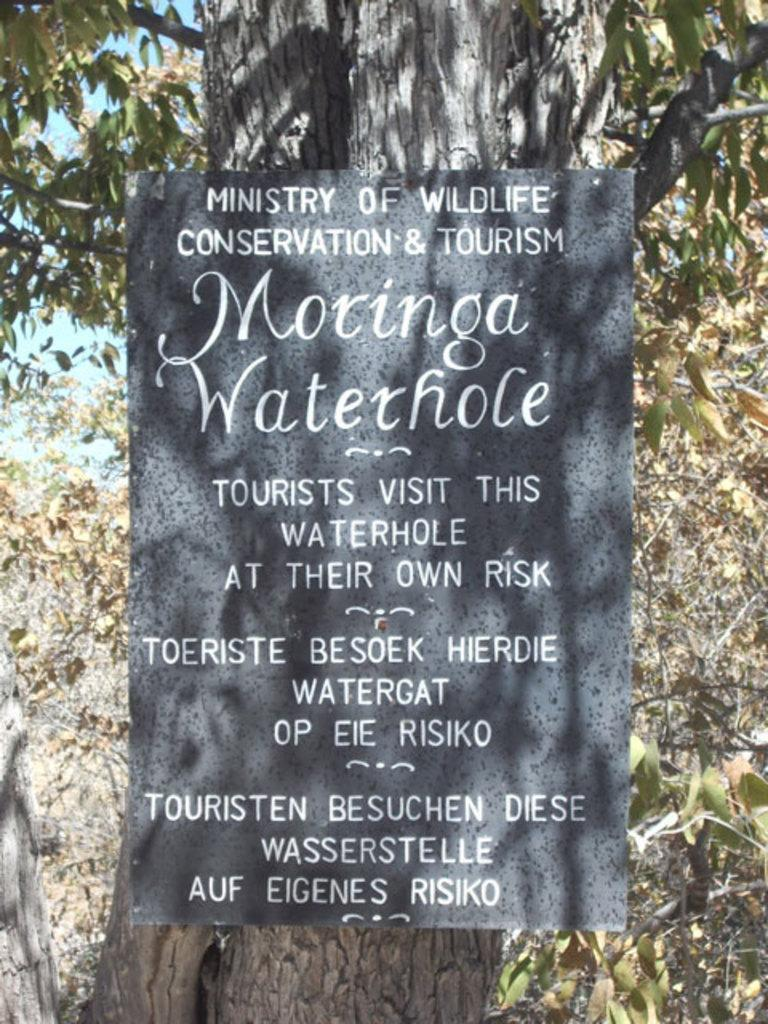What is the main object in the center of the image? There is a board in the center of the image. What can be seen in the background of the image? There are trees and the sky visible in the background of the image. What type of sweater is being worn by the celery in the image? There is no sweater or celery present in the image; it only features a board and background elements. 